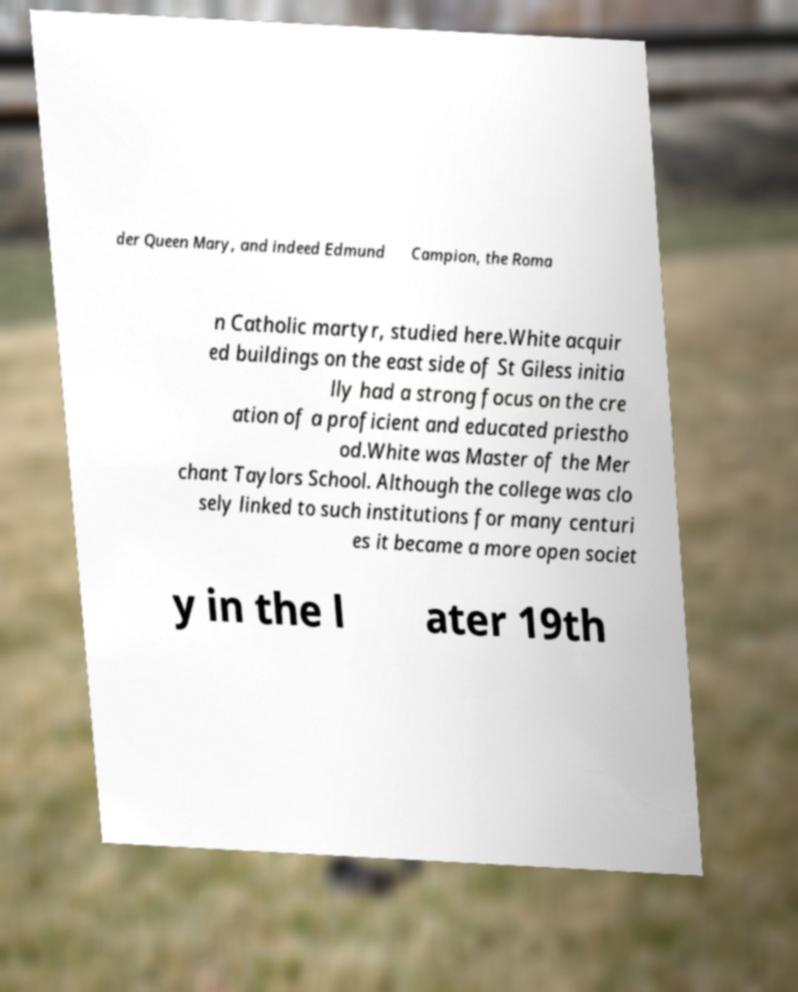For documentation purposes, I need the text within this image transcribed. Could you provide that? der Queen Mary, and indeed Edmund Campion, the Roma n Catholic martyr, studied here.White acquir ed buildings on the east side of St Giless initia lly had a strong focus on the cre ation of a proficient and educated priestho od.White was Master of the Mer chant Taylors School. Although the college was clo sely linked to such institutions for many centuri es it became a more open societ y in the l ater 19th 